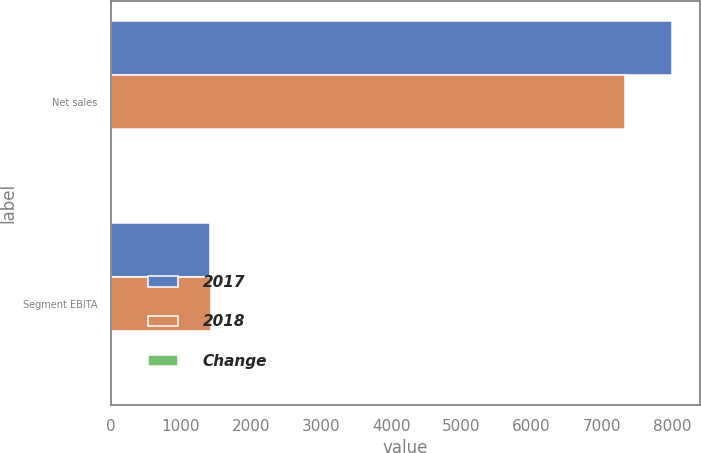Convert chart. <chart><loc_0><loc_0><loc_500><loc_500><stacked_bar_chart><ecel><fcel>Net sales<fcel>Segment EBITA<nl><fcel>2017<fcel>8000<fcel>1417<nl><fcel>2018<fcel>7337<fcel>1427<nl><fcel>Change<fcel>9<fcel>1<nl></chart> 